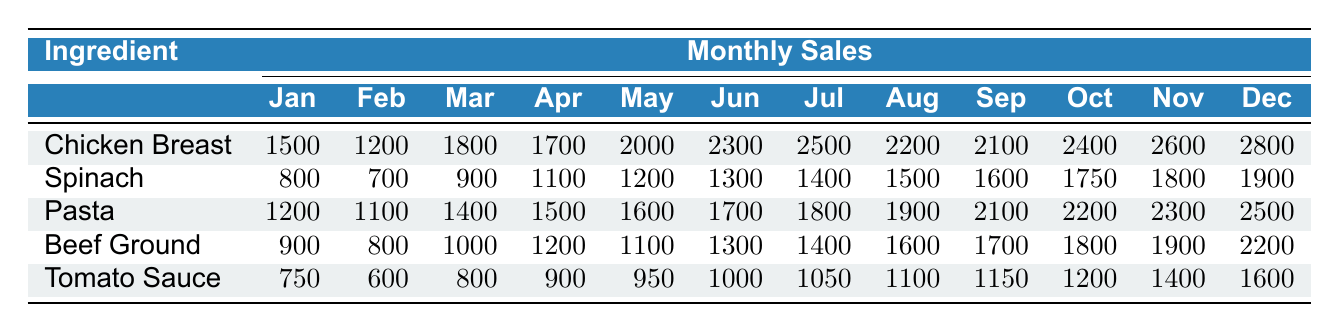What was the highest sales amount for Chicken Breast? The highest sales amount for Chicken Breast can be found in the December row, which shows a value of 2800.
Answer: 2800 In which month did Spinach sales first exceed 1500? Looking at the monthly sales data for Spinach, sales first exceeded 1500 in August, which shows a value of 1500 for that month.
Answer: August What is the total sales for Pasta from January to March? The total sales for Pasta for January (1200), February (1100), and March (1400) can be calculated as 1200 + 1100 + 1400 = 3700.
Answer: 3700 Is the sales trend for Tomato Sauce increasing consistently from January to December? No, the sales for Tomato Sauce do not show a consistent increase. For instance, the sales decreased from 750 in January to 600 in February, indicating a drop.
Answer: No What is the average monthly sales for Beef Ground from April to July? The monthly sales for Beef Ground from April to July are: April (1200), May (1100), June (1300), July (1400). The sum is 1200 + 1100 + 1300 + 1400 = 5000, and there are 4 months, so the average is 5000 / 4 = 1250.
Answer: 1250 Which ingredient had the highest total sales in December? By checking the December sales, Chicken Breast had the highest total with 2800, compared to other ingredients: Spinach (1900), Pasta (2500), Beef Ground (2200), and Tomato Sauce (1600).
Answer: Chicken Breast What is the difference in sales between the highest and lowest months for Tomato Sauce? The highest sales month for Tomato Sauce is December (1600) and the lowest is February (600). The difference is 1600 - 600 = 1000.
Answer: 1000 What was the sales trend for Chicken Breast between January and July? The sales for Chicken Breast increased from January (1500) to July (2500), showing a steady upward trend for each month.
Answer: Increasing Which ingredient had the smallest sales in January? By comparing the January sales of all ingredients, Tomato Sauce had the smallest sales at 750, while others had higher sales: Chicken Breast (1500), Spinach (800), Pasta (1200), and Beef Ground (900).
Answer: Tomato Sauce 